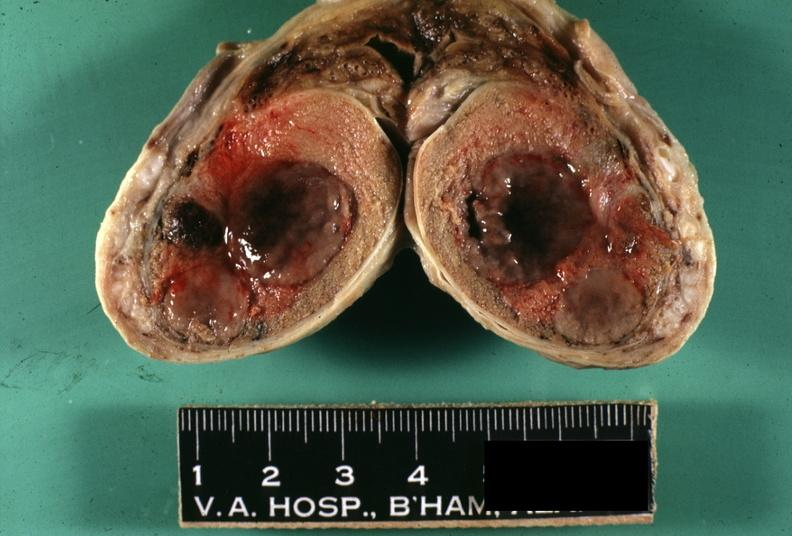what is present?
Answer the question using a single word or phrase. Testicle 